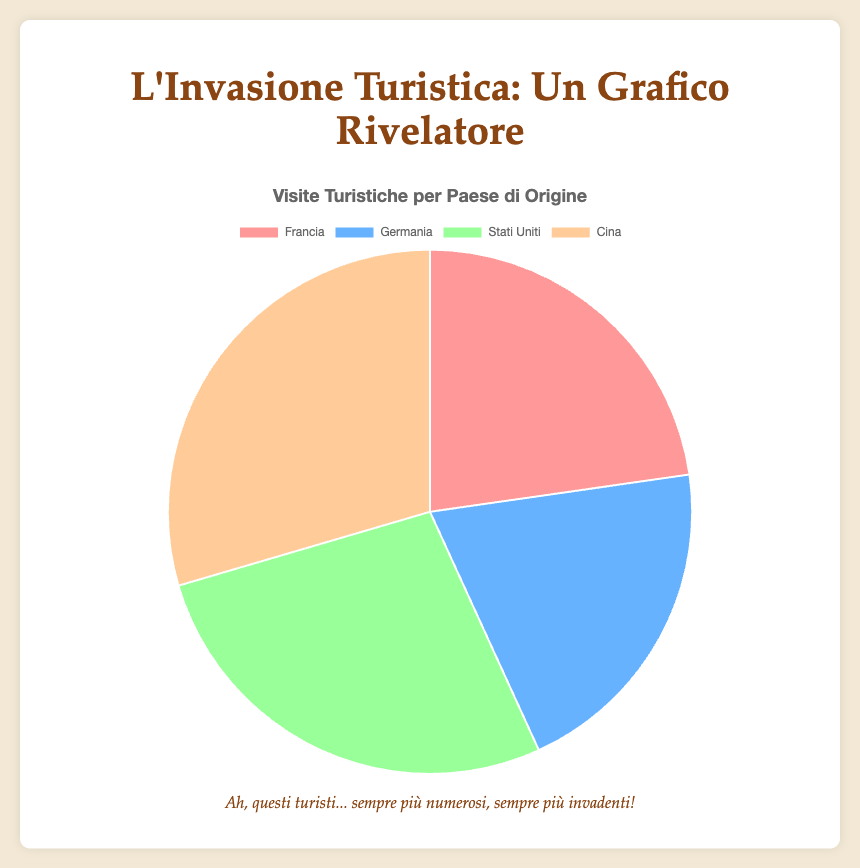Which country has the highest number of tourist visits? China has the highest number of tourist visits. This is determined by looking at the largest segment of the pie chart, which corresponds to 650,000 visits.
Answer: China Which countries have fewer tourist visits than the USA? Both France and Germany have fewer tourist visits than the USA. France has 500,000 visits and Germany has 450,000 visits, while the USA has 600,000 visits.
Answer: France, Germany What is the total number of tourist visits from all four countries? To find the total number of tourist visits, add the visits from all four countries: 500,000 (France) + 450,000 (Germany) + 600,000 (USA) + 650,000 (China) = 2,200,000 visits.
Answer: 2,200,000 By how much does China's tourist visits exceed France's tourist visits? Subtract France's 500,000 visits from China's 650,000 visits: 650,000 - 500,000 = 150,000.
Answer: 150,000 Which country contributes the smallest portion of tourist visits to the chart? Germany contributes the smallest portion of tourist visits, as it has the smallest segment in the pie chart, representing 450,000 visits.
Answer: Germany What is the average number of tourist visits across all four countries? To find the average, sum the visits and divide by the number of countries: (500,000 + 450,000 + 600,000 + 650,000) / 4 = 2,200,000 / 4 = 550,000.
Answer: 550,000 What is the combined percentage of visits from Germany and France out of the total visits? First, find the sum of visits from Germany and France: 450,000 + 500,000 = 950,000. Then, divide by the total number of visits (2,200,000) and multiply by 100 to find the percentage: (950,000 / 2,200,000) * 100 ≈ 43.18%.
Answer: 43.18% Rank the countries from highest to lowest according to the number of tourist visits. First is China with 650,000 visits, followed by the USA with 600,000 visits, then France with 500,000 visits, and finally Germany with 450,000 visits.
Answer: China, USA, France, Germany 